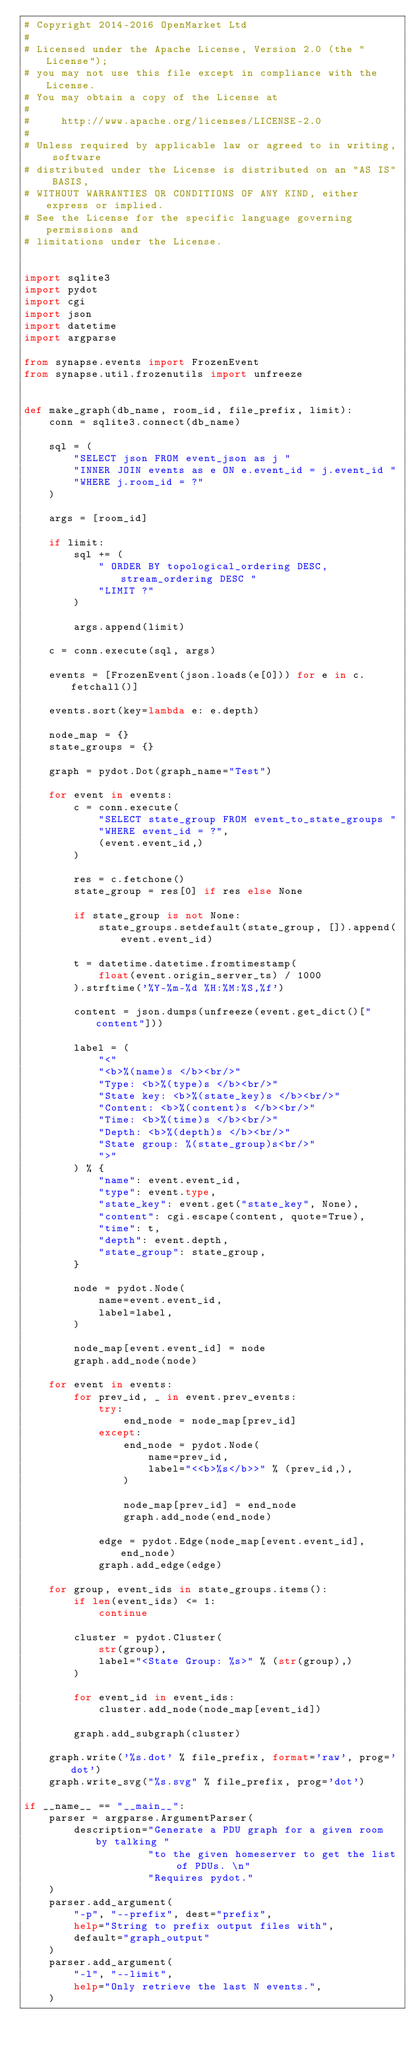Convert code to text. <code><loc_0><loc_0><loc_500><loc_500><_Python_># Copyright 2014-2016 OpenMarket Ltd
#
# Licensed under the Apache License, Version 2.0 (the "License");
# you may not use this file except in compliance with the License.
# You may obtain a copy of the License at
#
#     http://www.apache.org/licenses/LICENSE-2.0
#
# Unless required by applicable law or agreed to in writing, software
# distributed under the License is distributed on an "AS IS" BASIS,
# WITHOUT WARRANTIES OR CONDITIONS OF ANY KIND, either express or implied.
# See the License for the specific language governing permissions and
# limitations under the License.


import sqlite3
import pydot
import cgi
import json
import datetime
import argparse

from synapse.events import FrozenEvent
from synapse.util.frozenutils import unfreeze


def make_graph(db_name, room_id, file_prefix, limit):
    conn = sqlite3.connect(db_name)

    sql = (
        "SELECT json FROM event_json as j "
        "INNER JOIN events as e ON e.event_id = j.event_id "
        "WHERE j.room_id = ?"
    )

    args = [room_id]

    if limit:
        sql += (
            " ORDER BY topological_ordering DESC, stream_ordering DESC "
            "LIMIT ?"
        )

        args.append(limit)

    c = conn.execute(sql, args)

    events = [FrozenEvent(json.loads(e[0])) for e in c.fetchall()]

    events.sort(key=lambda e: e.depth)

    node_map = {}
    state_groups = {}

    graph = pydot.Dot(graph_name="Test")

    for event in events:
        c = conn.execute(
            "SELECT state_group FROM event_to_state_groups "
            "WHERE event_id = ?",
            (event.event_id,)
        )

        res = c.fetchone()
        state_group = res[0] if res else None

        if state_group is not None:
            state_groups.setdefault(state_group, []).append(event.event_id)

        t = datetime.datetime.fromtimestamp(
            float(event.origin_server_ts) / 1000
        ).strftime('%Y-%m-%d %H:%M:%S,%f')

        content = json.dumps(unfreeze(event.get_dict()["content"]))

        label = (
            "<"
            "<b>%(name)s </b><br/>"
            "Type: <b>%(type)s </b><br/>"
            "State key: <b>%(state_key)s </b><br/>"
            "Content: <b>%(content)s </b><br/>"
            "Time: <b>%(time)s </b><br/>"
            "Depth: <b>%(depth)s </b><br/>"
            "State group: %(state_group)s<br/>"
            ">"
        ) % {
            "name": event.event_id,
            "type": event.type,
            "state_key": event.get("state_key", None),
            "content": cgi.escape(content, quote=True),
            "time": t,
            "depth": event.depth,
            "state_group": state_group,
        }

        node = pydot.Node(
            name=event.event_id,
            label=label,
        )

        node_map[event.event_id] = node
        graph.add_node(node)

    for event in events:
        for prev_id, _ in event.prev_events:
            try:
                end_node = node_map[prev_id]
            except:
                end_node = pydot.Node(
                    name=prev_id,
                    label="<<b>%s</b>>" % (prev_id,),
                )

                node_map[prev_id] = end_node
                graph.add_node(end_node)

            edge = pydot.Edge(node_map[event.event_id], end_node)
            graph.add_edge(edge)

    for group, event_ids in state_groups.items():
        if len(event_ids) <= 1:
            continue

        cluster = pydot.Cluster(
            str(group),
            label="<State Group: %s>" % (str(group),)
        )

        for event_id in event_ids:
            cluster.add_node(node_map[event_id])

        graph.add_subgraph(cluster)

    graph.write('%s.dot' % file_prefix, format='raw', prog='dot')
    graph.write_svg("%s.svg" % file_prefix, prog='dot')

if __name__ == "__main__":
    parser = argparse.ArgumentParser(
        description="Generate a PDU graph for a given room by talking "
                    "to the given homeserver to get the list of PDUs. \n"
                    "Requires pydot."
    )
    parser.add_argument(
        "-p", "--prefix", dest="prefix",
        help="String to prefix output files with",
        default="graph_output"
    )
    parser.add_argument(
        "-l", "--limit",
        help="Only retrieve the last N events.",
    )</code> 